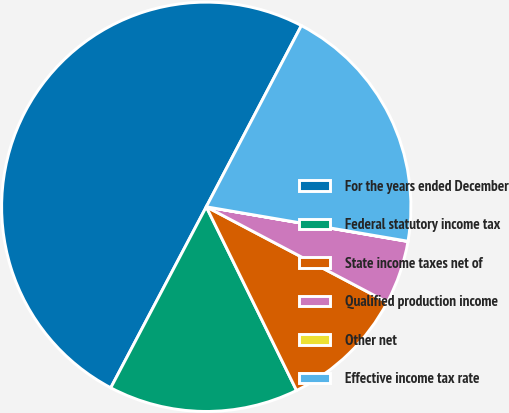<chart> <loc_0><loc_0><loc_500><loc_500><pie_chart><fcel>For the years ended December<fcel>Federal statutory income tax<fcel>State income taxes net of<fcel>Qualified production income<fcel>Other net<fcel>Effective income tax rate<nl><fcel>49.97%<fcel>15.0%<fcel>10.01%<fcel>5.01%<fcel>0.02%<fcel>20.0%<nl></chart> 